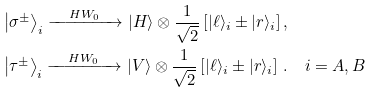<formula> <loc_0><loc_0><loc_500><loc_500>& \left | \sigma ^ { \pm } \right \rangle _ { i } \xrightarrow { \quad H W _ { 0 } \quad } | H \rangle \otimes \frac { 1 } { \sqrt { 2 } } \left [ | \ell \rangle _ { i } \pm | r \rangle _ { i } \right ] , \\ & \left | \tau ^ { \pm } \right \rangle _ { i } \xrightarrow { \quad H W _ { 0 } \quad } | V \rangle \otimes \frac { 1 } { \sqrt { 2 } } \left [ | \ell \rangle _ { i } \pm | r \rangle _ { i } \right ] \, . \quad i = A , B</formula> 